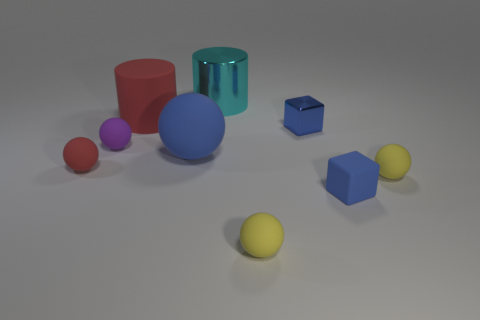There is a large object that is the same color as the small metallic block; what is its shape?
Offer a terse response. Sphere. There is a big thing that is the same shape as the small red matte thing; what is its color?
Keep it short and to the point. Blue. How big is the purple sphere?
Make the answer very short. Small. Are there fewer rubber spheres in front of the large metal thing than small blue matte blocks?
Your answer should be compact. No. Does the blue sphere have the same material as the yellow ball that is right of the tiny metallic thing?
Give a very brief answer. Yes. Is there a matte sphere that is to the right of the small sphere on the left side of the tiny rubber thing behind the large blue sphere?
Give a very brief answer. Yes. Are there any other things that have the same size as the cyan thing?
Your answer should be compact. Yes. The big object that is the same material as the large blue ball is what color?
Provide a succinct answer. Red. How big is the ball that is left of the big blue thing and right of the red matte ball?
Provide a succinct answer. Small. Is the number of spheres that are to the left of the shiny block less than the number of large spheres that are on the left side of the small purple matte object?
Give a very brief answer. No. 